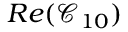<formula> <loc_0><loc_0><loc_500><loc_500>R e ( \mathcal { C } _ { 1 0 } )</formula> 